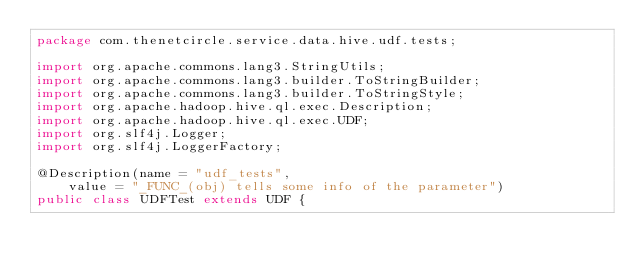<code> <loc_0><loc_0><loc_500><loc_500><_Java_>package com.thenetcircle.service.data.hive.udf.tests;

import org.apache.commons.lang3.StringUtils;
import org.apache.commons.lang3.builder.ToStringBuilder;
import org.apache.commons.lang3.builder.ToStringStyle;
import org.apache.hadoop.hive.ql.exec.Description;
import org.apache.hadoop.hive.ql.exec.UDF;
import org.slf4j.Logger;
import org.slf4j.LoggerFactory;

@Description(name = "udf_tests",
    value = "_FUNC_(obj) tells some info of the parameter")
public class UDFTest extends UDF {</code> 